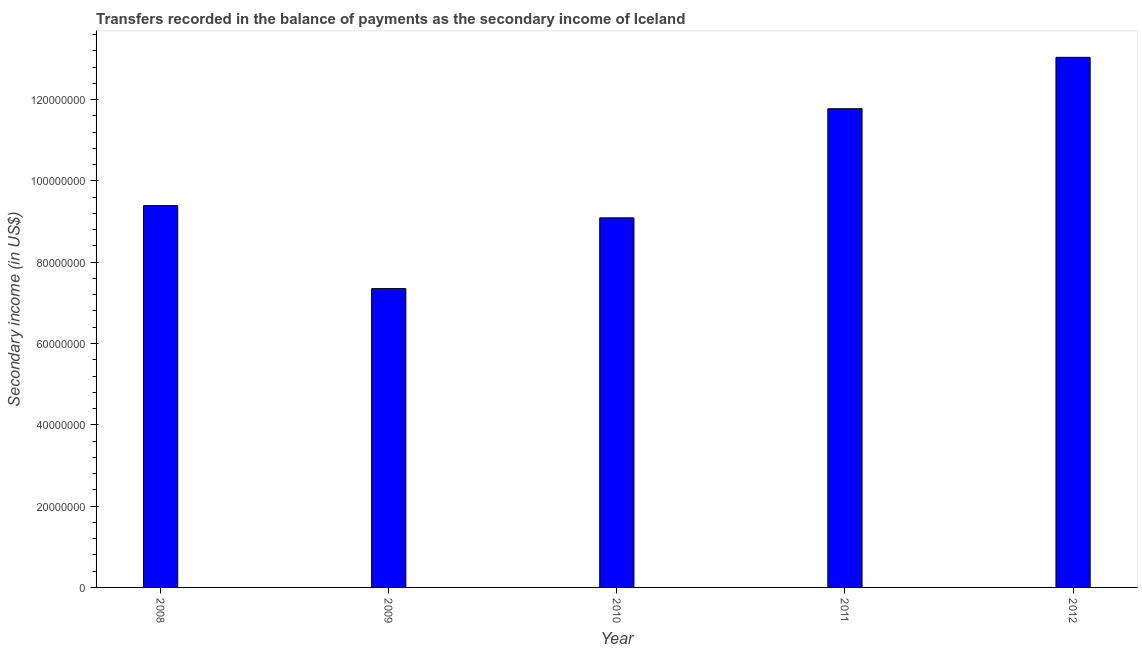Does the graph contain any zero values?
Give a very brief answer. No. Does the graph contain grids?
Make the answer very short. No. What is the title of the graph?
Keep it short and to the point. Transfers recorded in the balance of payments as the secondary income of Iceland. What is the label or title of the X-axis?
Make the answer very short. Year. What is the label or title of the Y-axis?
Your answer should be very brief. Secondary income (in US$). What is the amount of secondary income in 2009?
Give a very brief answer. 7.35e+07. Across all years, what is the maximum amount of secondary income?
Provide a short and direct response. 1.30e+08. Across all years, what is the minimum amount of secondary income?
Give a very brief answer. 7.35e+07. What is the sum of the amount of secondary income?
Make the answer very short. 5.06e+08. What is the difference between the amount of secondary income in 2009 and 2012?
Offer a very short reply. -5.69e+07. What is the average amount of secondary income per year?
Ensure brevity in your answer.  1.01e+08. What is the median amount of secondary income?
Keep it short and to the point. 9.39e+07. In how many years, is the amount of secondary income greater than 28000000 US$?
Your response must be concise. 5. Do a majority of the years between 2009 and 2010 (inclusive) have amount of secondary income greater than 120000000 US$?
Give a very brief answer. No. What is the ratio of the amount of secondary income in 2008 to that in 2009?
Offer a terse response. 1.28. Is the amount of secondary income in 2010 less than that in 2011?
Offer a very short reply. Yes. What is the difference between the highest and the second highest amount of secondary income?
Give a very brief answer. 1.26e+07. What is the difference between the highest and the lowest amount of secondary income?
Your answer should be compact. 5.69e+07. In how many years, is the amount of secondary income greater than the average amount of secondary income taken over all years?
Your answer should be compact. 2. How many bars are there?
Make the answer very short. 5. What is the Secondary income (in US$) in 2008?
Your response must be concise. 9.39e+07. What is the Secondary income (in US$) in 2009?
Provide a succinct answer. 7.35e+07. What is the Secondary income (in US$) in 2010?
Your answer should be compact. 9.09e+07. What is the Secondary income (in US$) in 2011?
Make the answer very short. 1.18e+08. What is the Secondary income (in US$) in 2012?
Your answer should be compact. 1.30e+08. What is the difference between the Secondary income (in US$) in 2008 and 2009?
Provide a short and direct response. 2.04e+07. What is the difference between the Secondary income (in US$) in 2008 and 2010?
Give a very brief answer. 3.00e+06. What is the difference between the Secondary income (in US$) in 2008 and 2011?
Give a very brief answer. -2.38e+07. What is the difference between the Secondary income (in US$) in 2008 and 2012?
Provide a short and direct response. -3.65e+07. What is the difference between the Secondary income (in US$) in 2009 and 2010?
Provide a short and direct response. -1.74e+07. What is the difference between the Secondary income (in US$) in 2009 and 2011?
Offer a very short reply. -4.43e+07. What is the difference between the Secondary income (in US$) in 2009 and 2012?
Your answer should be compact. -5.69e+07. What is the difference between the Secondary income (in US$) in 2010 and 2011?
Your answer should be compact. -2.68e+07. What is the difference between the Secondary income (in US$) in 2010 and 2012?
Offer a very short reply. -3.95e+07. What is the difference between the Secondary income (in US$) in 2011 and 2012?
Provide a succinct answer. -1.26e+07. What is the ratio of the Secondary income (in US$) in 2008 to that in 2009?
Your answer should be very brief. 1.28. What is the ratio of the Secondary income (in US$) in 2008 to that in 2010?
Offer a very short reply. 1.03. What is the ratio of the Secondary income (in US$) in 2008 to that in 2011?
Give a very brief answer. 0.8. What is the ratio of the Secondary income (in US$) in 2008 to that in 2012?
Keep it short and to the point. 0.72. What is the ratio of the Secondary income (in US$) in 2009 to that in 2010?
Offer a very short reply. 0.81. What is the ratio of the Secondary income (in US$) in 2009 to that in 2011?
Give a very brief answer. 0.62. What is the ratio of the Secondary income (in US$) in 2009 to that in 2012?
Provide a short and direct response. 0.56. What is the ratio of the Secondary income (in US$) in 2010 to that in 2011?
Offer a terse response. 0.77. What is the ratio of the Secondary income (in US$) in 2010 to that in 2012?
Ensure brevity in your answer.  0.7. What is the ratio of the Secondary income (in US$) in 2011 to that in 2012?
Your answer should be compact. 0.9. 